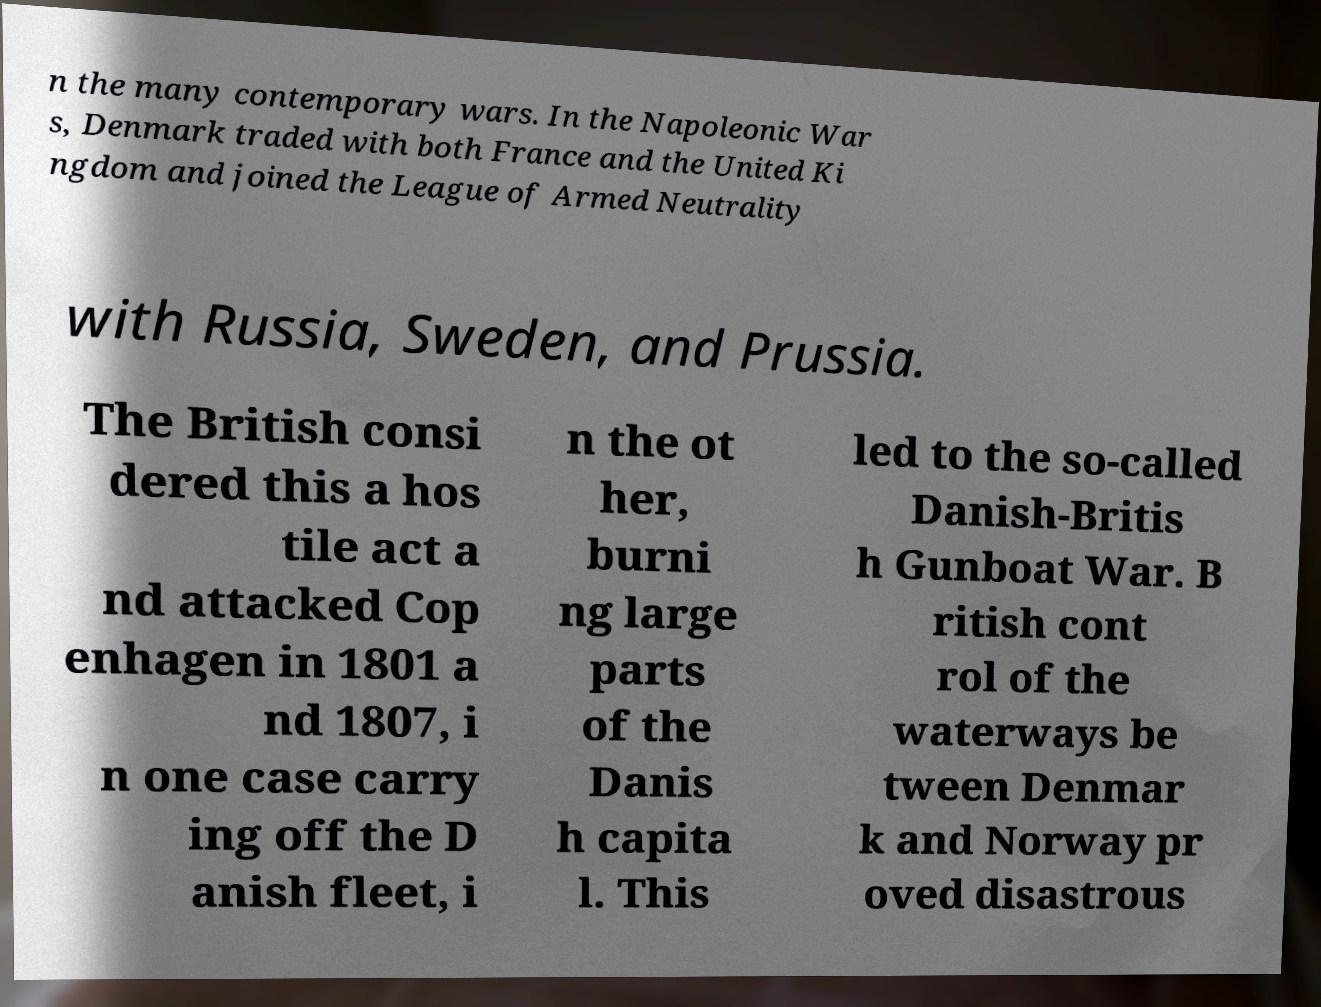Please read and relay the text visible in this image. What does it say? n the many contemporary wars. In the Napoleonic War s, Denmark traded with both France and the United Ki ngdom and joined the League of Armed Neutrality with Russia, Sweden, and Prussia. The British consi dered this a hos tile act a nd attacked Cop enhagen in 1801 a nd 1807, i n one case carry ing off the D anish fleet, i n the ot her, burni ng large parts of the Danis h capita l. This led to the so-called Danish-Britis h Gunboat War. B ritish cont rol of the waterways be tween Denmar k and Norway pr oved disastrous 